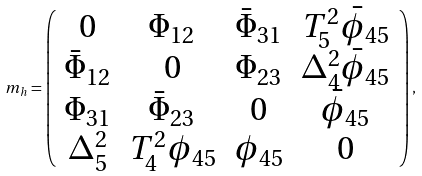<formula> <loc_0><loc_0><loc_500><loc_500>m _ { h } = \left ( \begin{array} { c c c c } { 0 } & { { \Phi _ { 1 2 } } } & { { \bar { \Phi } _ { 3 1 } } } & { { T _ { 5 } ^ { 2 } \bar { \phi } _ { 4 5 } } } \\ { { \bar { \Phi } _ { 1 2 } } } & { 0 } & { { \Phi _ { 2 3 } } } & { { \Delta _ { 4 } ^ { 2 } \bar { \phi } _ { 4 5 } } } \\ { { \Phi _ { 3 1 } } } & { { \bar { \Phi } _ { 2 3 } } } & { 0 } & { { \bar { \phi } _ { 4 5 } } } \\ { { \Delta _ { 5 } ^ { 2 } } } & { { T _ { 4 } ^ { 2 } \phi _ { 4 5 } } } & { { \phi _ { 4 5 } } } & { 0 } \end{array} \right ) ,</formula> 